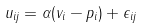<formula> <loc_0><loc_0><loc_500><loc_500>u _ { i j } = \alpha ( v _ { i } - p _ { i } ) + \epsilon _ { i j }</formula> 